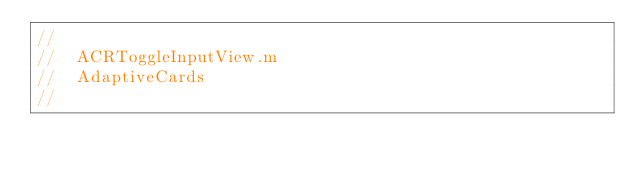<code> <loc_0><loc_0><loc_500><loc_500><_ObjectiveC_>//
//  ACRToggleInputView.m
//  AdaptiveCards
//</code> 